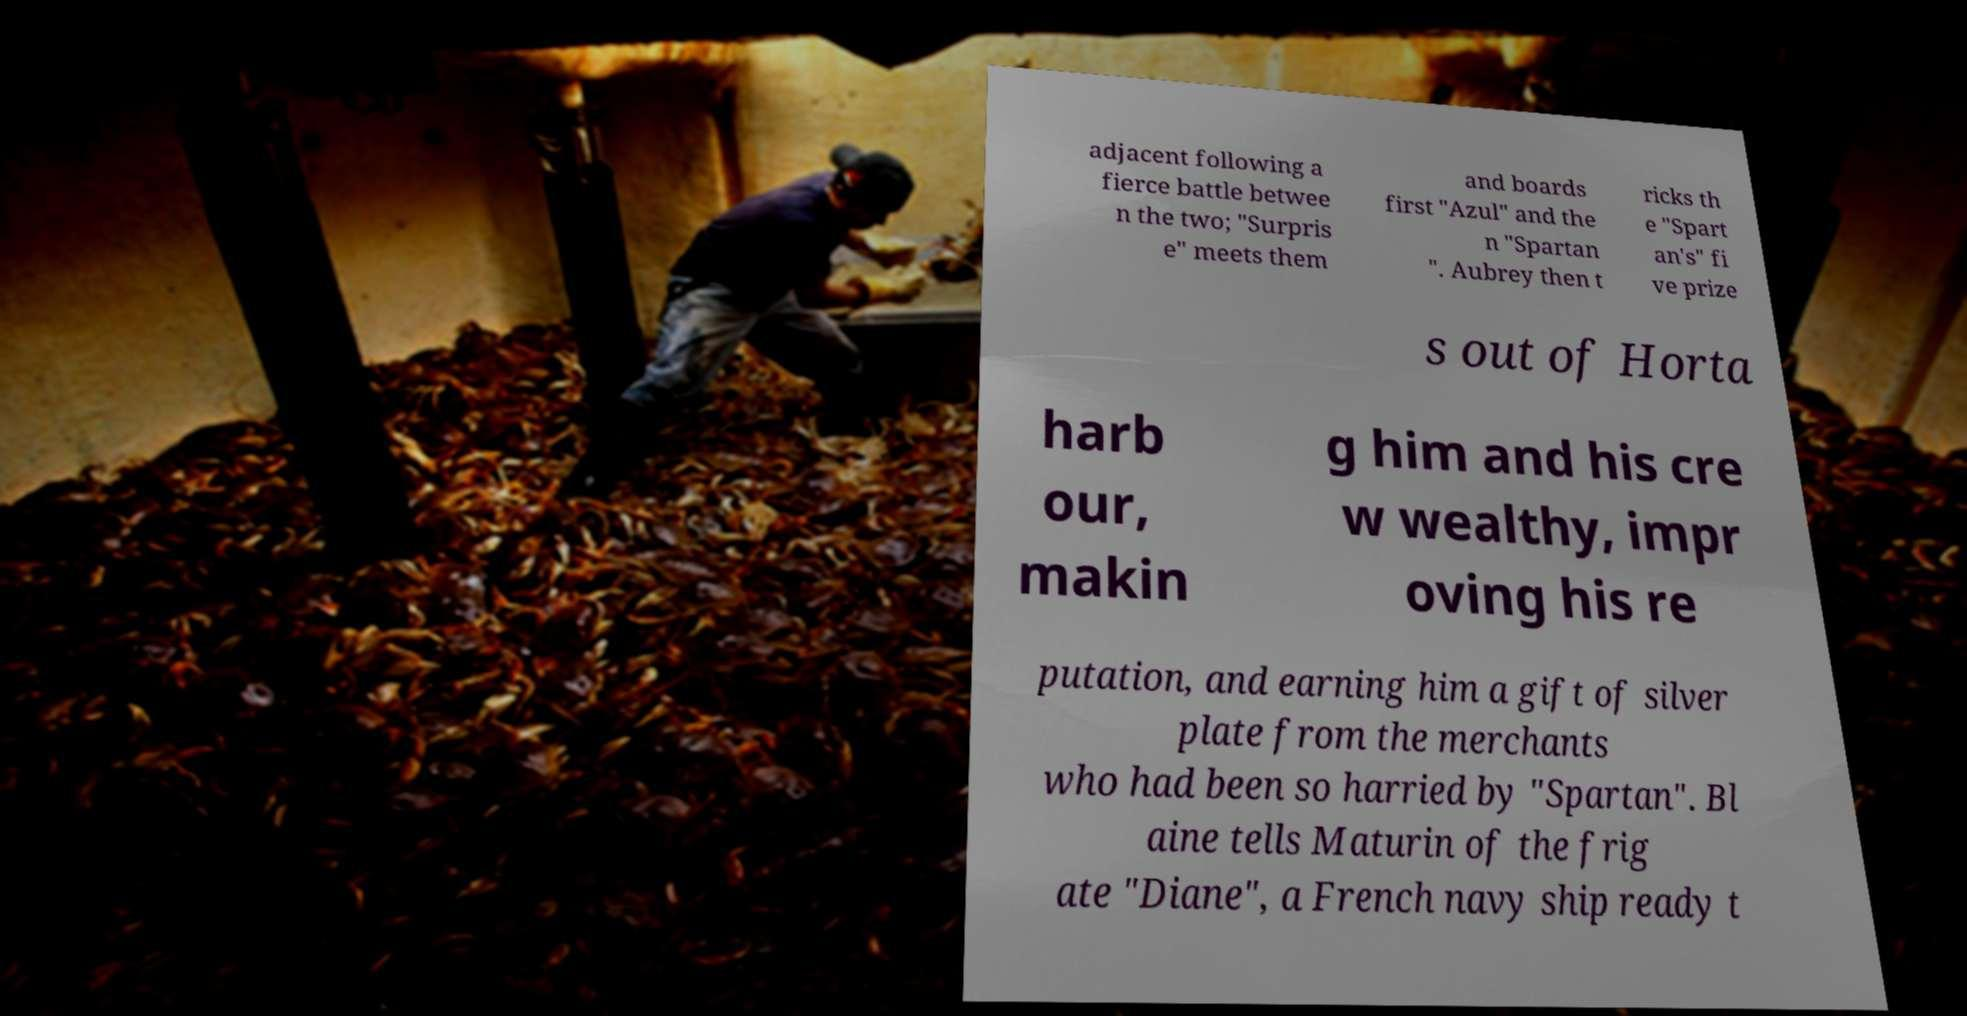What messages or text are displayed in this image? I need them in a readable, typed format. adjacent following a fierce battle betwee n the two; "Surpris e" meets them and boards first "Azul" and the n "Spartan ". Aubrey then t ricks th e "Spart an's" fi ve prize s out of Horta harb our, makin g him and his cre w wealthy, impr oving his re putation, and earning him a gift of silver plate from the merchants who had been so harried by "Spartan". Bl aine tells Maturin of the frig ate "Diane", a French navy ship ready t 